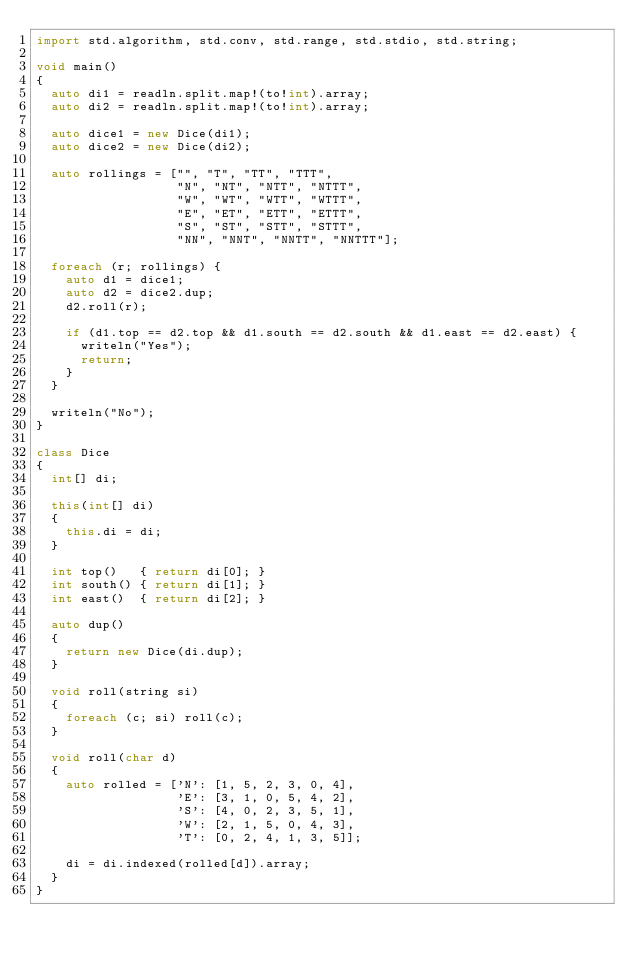<code> <loc_0><loc_0><loc_500><loc_500><_D_>import std.algorithm, std.conv, std.range, std.stdio, std.string;

void main()
{
  auto di1 = readln.split.map!(to!int).array;
  auto di2 = readln.split.map!(to!int).array;

  auto dice1 = new Dice(di1);
  auto dice2 = new Dice(di2);

  auto rollings = ["", "T", "TT", "TTT",
                   "N", "NT", "NTT", "NTTT",
                   "W", "WT", "WTT", "WTTT",
                   "E", "ET", "ETT", "ETTT",
                   "S", "ST", "STT", "STTT",
                   "NN", "NNT", "NNTT", "NNTTT"];

  foreach (r; rollings) {
    auto d1 = dice1;
    auto d2 = dice2.dup;
    d2.roll(r);

    if (d1.top == d2.top && d1.south == d2.south && d1.east == d2.east) {
      writeln("Yes");
      return;
    }
  }

  writeln("No");
}

class Dice
{
  int[] di;

  this(int[] di)
  {
    this.di = di;
  }

  int top()   { return di[0]; }
  int south() { return di[1]; }
  int east()  { return di[2]; }

  auto dup()
  {
    return new Dice(di.dup);
  }

  void roll(string si)
  {
    foreach (c; si) roll(c);
  }

  void roll(char d)
  {
    auto rolled = ['N': [1, 5, 2, 3, 0, 4],
                   'E': [3, 1, 0, 5, 4, 2],
                   'S': [4, 0, 2, 3, 5, 1],
                   'W': [2, 1, 5, 0, 4, 3],
                   'T': [0, 2, 4, 1, 3, 5]];

    di = di.indexed(rolled[d]).array;
  }
}</code> 